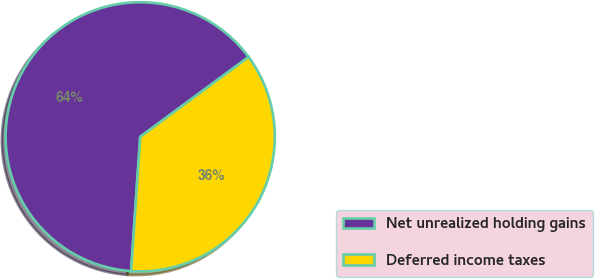Convert chart. <chart><loc_0><loc_0><loc_500><loc_500><pie_chart><fcel>Net unrealized holding gains<fcel>Deferred income taxes<nl><fcel>63.82%<fcel>36.18%<nl></chart> 